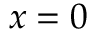Convert formula to latex. <formula><loc_0><loc_0><loc_500><loc_500>x = 0</formula> 